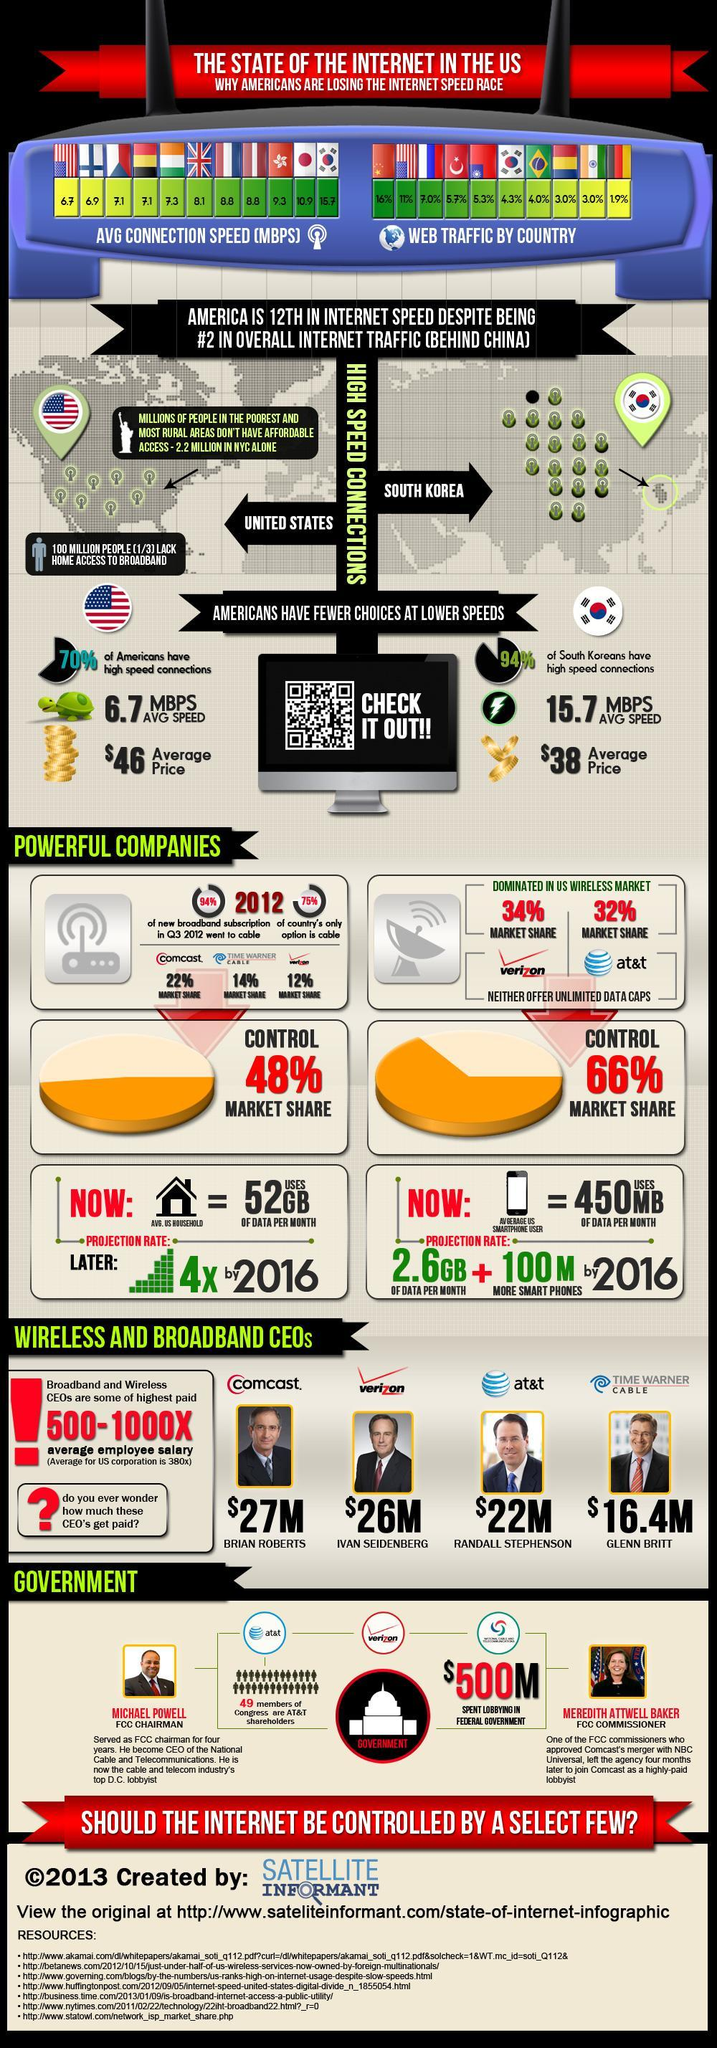What is the market share of Comcast in the US wireless market in 2012?
Answer the question with a short phrase. 22% What percentage of web traffic is contributed by South Korea in 2013? 4.3% What is the average internet connection speed (in MBPS) in the US in 2013? 6.7 What is the average internet connection speed (in MBPS) in the UK in 2013? 8.1 Which telecommunication company has contributed 34% in the US wireless market in 2012? verizon What type of broadband connection is used by 75% of the US population? cable Who was the wireless & broadband CEO of at&t in 2013? RANDALL STEPHENSON What is the average salary of Glenn Britt in 2013? $16.4M What percentage of web traffic is contributed by China in 2013? 16% 